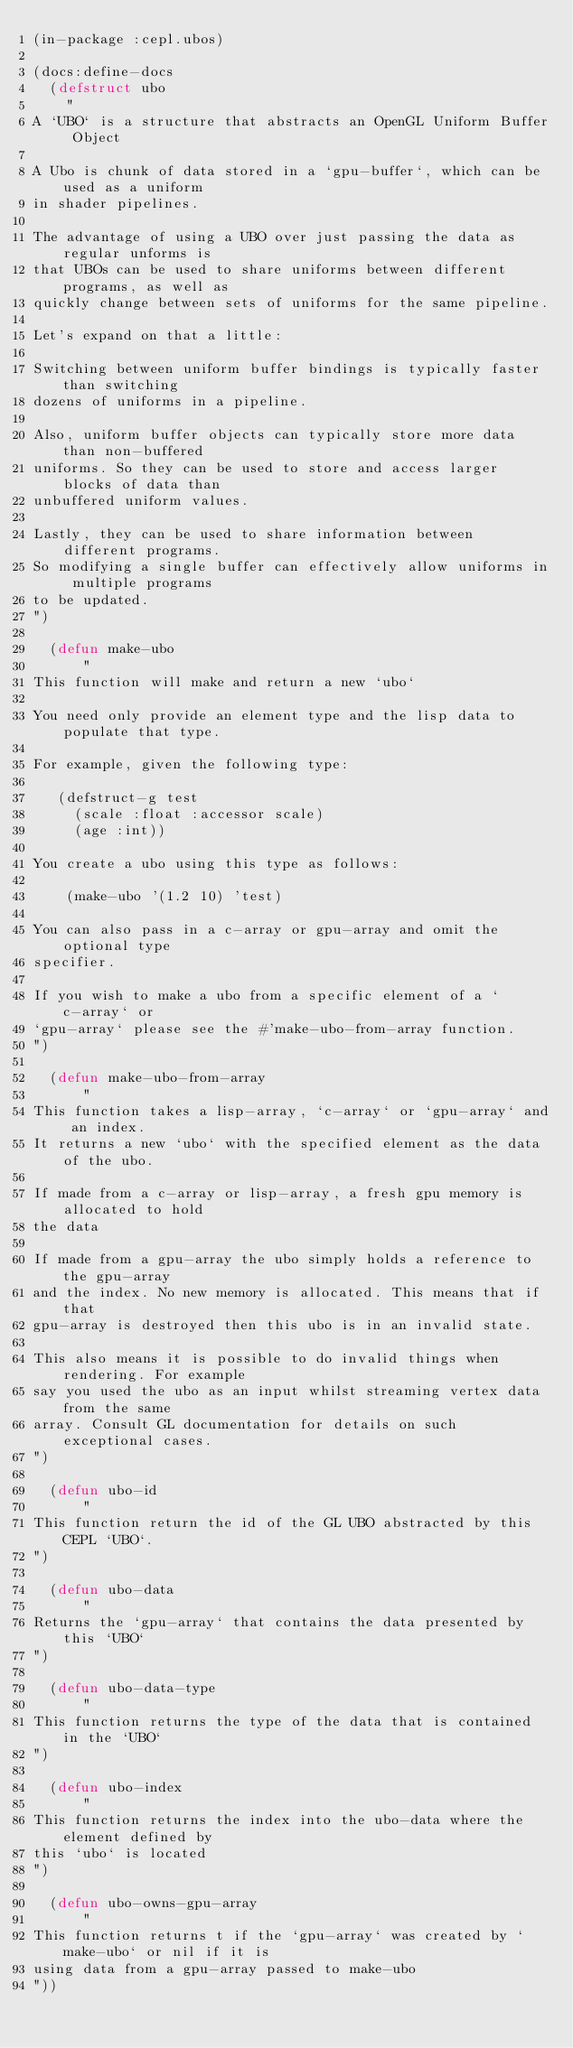Convert code to text. <code><loc_0><loc_0><loc_500><loc_500><_Lisp_>(in-package :cepl.ubos)

(docs:define-docs
  (defstruct ubo
    "
A `UBO` is a structure that abstracts an OpenGL Uniform Buffer Object

A Ubo is chunk of data stored in a `gpu-buffer`, which can be used as a uniform
in shader pipelines.

The advantage of using a UBO over just passing the data as regular unforms is
that UBOs can be used to share uniforms between different programs, as well as
quickly change between sets of uniforms for the same pipeline.

Let's expand on that a little:

Switching between uniform buffer bindings is typically faster than switching
dozens of uniforms in a pipeline.

Also, uniform buffer objects can typically store more data than non-buffered
uniforms. So they can be used to store and access larger blocks of data than
unbuffered uniform values.

Lastly, they can be used to share information between different programs.
So modifying a single buffer can effectively allow uniforms in multiple programs
to be updated.
")

  (defun make-ubo
      "
This function will make and return a new `ubo`

You need only provide an element type and the lisp data to populate that type.

For example, given the following type:

   (defstruct-g test
     (scale :float :accessor scale)
     (age :int))

You create a ubo using this type as follows:

    (make-ubo '(1.2 10) 'test)

You can also pass in a c-array or gpu-array and omit the optional type
specifier.

If you wish to make a ubo from a specific element of a `c-array` or
`gpu-array` please see the #'make-ubo-from-array function.
")

  (defun make-ubo-from-array
      "
This function takes a lisp-array, `c-array` or `gpu-array` and an index.
It returns a new `ubo` with the specified element as the data of the ubo.

If made from a c-array or lisp-array, a fresh gpu memory is allocated to hold
the data

If made from a gpu-array the ubo simply holds a reference to the gpu-array
and the index. No new memory is allocated. This means that if that
gpu-array is destroyed then this ubo is in an invalid state.

This also means it is possible to do invalid things when rendering. For example
say you used the ubo as an input whilst streaming vertex data from the same
array. Consult GL documentation for details on such exceptional cases.
")

  (defun ubo-id
      "
This function return the id of the GL UBO abstracted by this CEPL `UBO`.
")

  (defun ubo-data
      "
Returns the `gpu-array` that contains the data presented by this `UBO`
")

  (defun ubo-data-type
      "
This function returns the type of the data that is contained in the `UBO`
")

  (defun ubo-index
      "
This function returns the index into the ubo-data where the element defined by
this `ubo` is located
")

  (defun ubo-owns-gpu-array
      "
This function returns t if the `gpu-array` was created by `make-ubo` or nil if it is
using data from a gpu-array passed to make-ubo
"))
</code> 